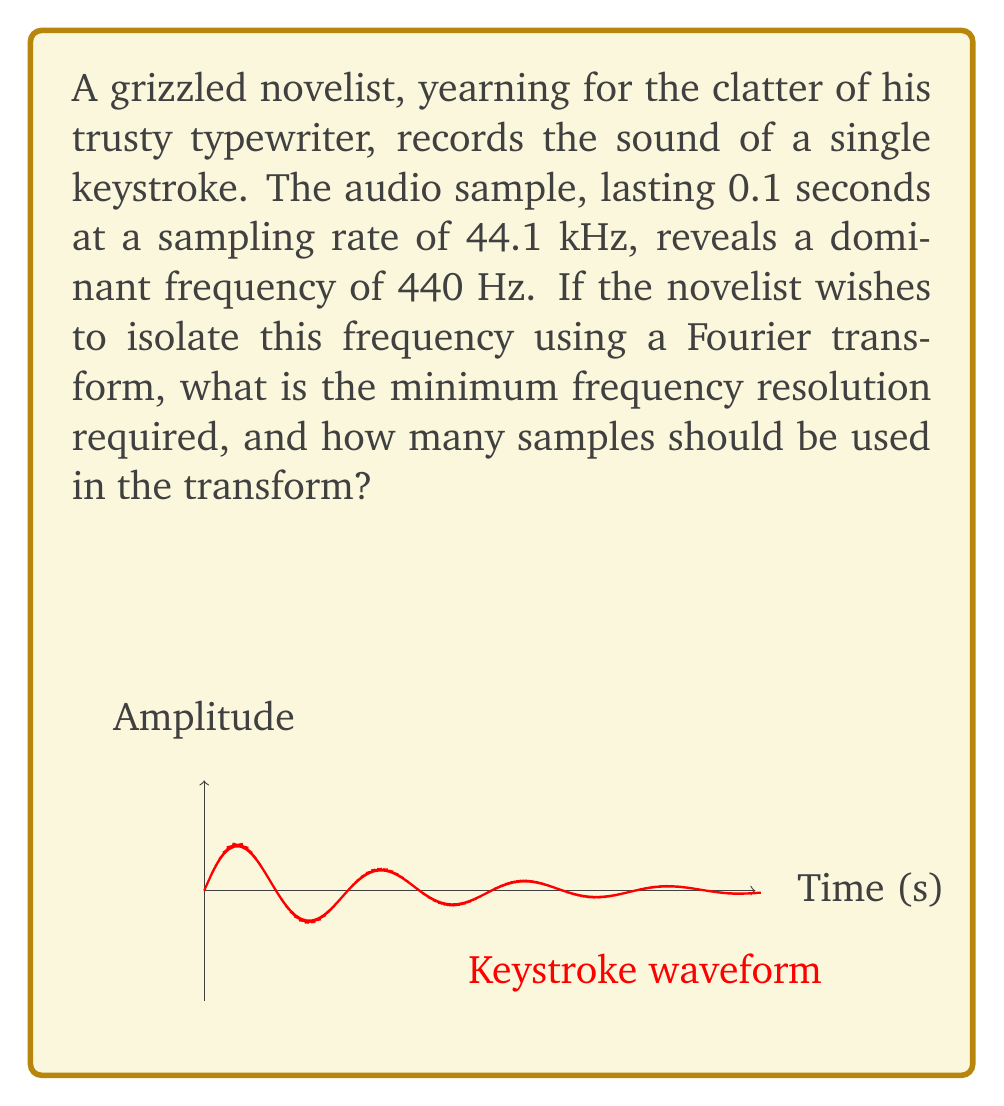Help me with this question. Let's approach this step-by-step:

1) The frequency resolution (Δf) in a Fourier transform is given by:

   $$\Delta f = \frac{f_s}{N}$$

   where $f_s$ is the sampling frequency and $N$ is the number of samples.

2) We want to isolate 440 Hz, so our frequency resolution should be at most 440 Hz. Let's choose 10 Hz for better precision:

   $$\Delta f = 10 \text{ Hz}$$

3) We know the sampling frequency $f_s = 44.1 \text{ kHz} = 44100 \text{ Hz}$

4) Substituting these into our equation:

   $$10 = \frac{44100}{N}$$

5) Solving for $N$:

   $$N = \frac{44100}{10} = 4410 \text{ samples}$$

6) The audio sample is 0.1 seconds long. At 44.1 kHz, this corresponds to:

   $$0.1 \times 44100 = 4410 \text{ samples}$$

7) This matches our calculated $N$, so we can use the entire audio sample for our transform.
Answer: 10 Hz resolution, 4410 samples 